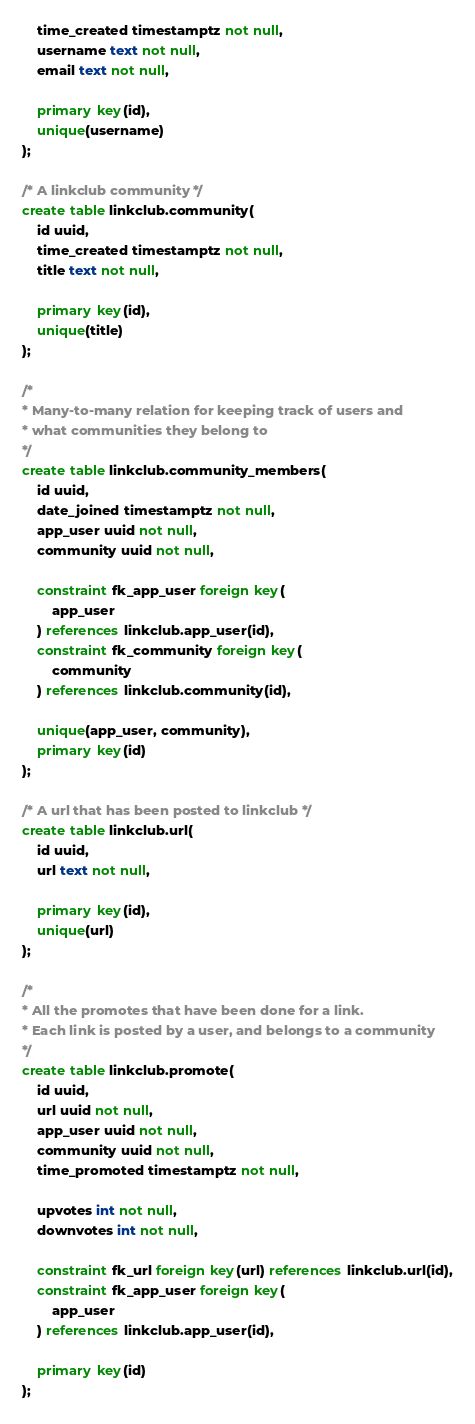Convert code to text. <code><loc_0><loc_0><loc_500><loc_500><_SQL_>    time_created timestamptz not null,
    username text not null,
    email text not null,

    primary key(id),
    unique(username)
);

/* A linkclub community */
create table linkclub.community(
    id uuid,
    time_created timestamptz not null,
    title text not null,

    primary key(id),
    unique(title)
);

/*
* Many-to-many relation for keeping track of users and
* what communities they belong to
*/
create table linkclub.community_members(
    id uuid,
    date_joined timestamptz not null,
    app_user uuid not null,
    community uuid not null,

    constraint fk_app_user foreign key(
        app_user
    ) references linkclub.app_user(id),
    constraint fk_community foreign key(
        community
    ) references linkclub.community(id),

    unique(app_user, community),
    primary key(id)
);

/* A url that has been posted to linkclub */
create table linkclub.url(
    id uuid,
    url text not null,

    primary key(id),
    unique(url)
);

/*
* All the promotes that have been done for a link.
* Each link is posted by a user, and belongs to a community
*/
create table linkclub.promote(
    id uuid,
    url uuid not null,
    app_user uuid not null,
    community uuid not null,
    time_promoted timestamptz not null,

    upvotes int not null,
    downvotes int not null,

    constraint fk_url foreign key(url) references linkclub.url(id),
    constraint fk_app_user foreign key(
        app_user
    ) references linkclub.app_user(id),

    primary key(id)
);
</code> 